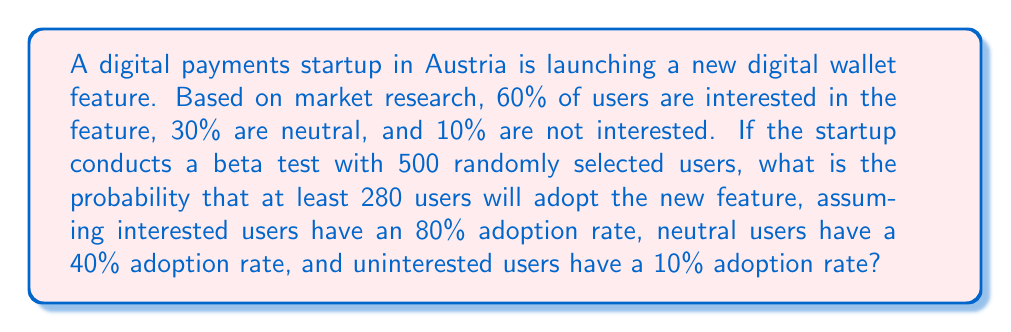Show me your answer to this math problem. Let's approach this step-by-step:

1) First, we need to calculate the overall probability of adoption for a single user:

   $P(\text{adoption}) = 0.60 \cdot 0.80 + 0.30 \cdot 0.40 + 0.10 \cdot 0.10 = 0.48 + 0.12 + 0.01 = 0.61$

2) Now, we can model this as a binomial distribution. We want the probability of 280 or more successes out of 500 trials, where each trial has a 0.61 probability of success.

3) The probability of exactly $k$ successes in $n$ trials is given by the binomial probability formula:

   $P(X = k) = \binom{n}{k} p^k (1-p)^{n-k}$

   where $n = 500$, $p = 0.61$, and $k$ ranges from 280 to 500.

4) We need to sum this probability for all values of $k$ from 280 to 500:

   $P(X \geq 280) = \sum_{k=280}^{500} \binom{500}{k} 0.61^k (1-0.61)^{500-k}$

5) This sum is difficult to calculate by hand, so we would typically use statistical software or a calculator with this capability. Using such a tool, we find:

   $P(X \geq 280) \approx 0.9987$

Thus, there is approximately a 99.87% chance that at least 280 users will adopt the new feature in the beta test.
Answer: 0.9987 